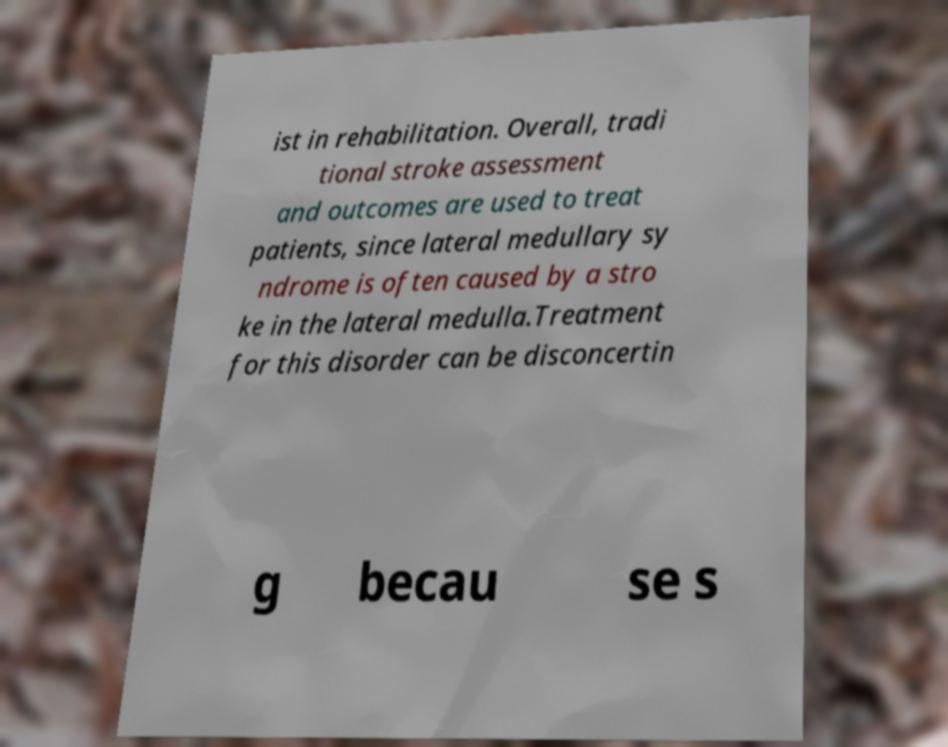What messages or text are displayed in this image? I need them in a readable, typed format. ist in rehabilitation. Overall, tradi tional stroke assessment and outcomes are used to treat patients, since lateral medullary sy ndrome is often caused by a stro ke in the lateral medulla.Treatment for this disorder can be disconcertin g becau se s 